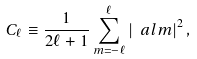<formula> <loc_0><loc_0><loc_500><loc_500>C _ { \ell } \equiv \frac { 1 } { 2 \ell + 1 } \sum _ { m = - \ell } ^ { \ell } \left | \ a l m \right | ^ { 2 } ,</formula> 